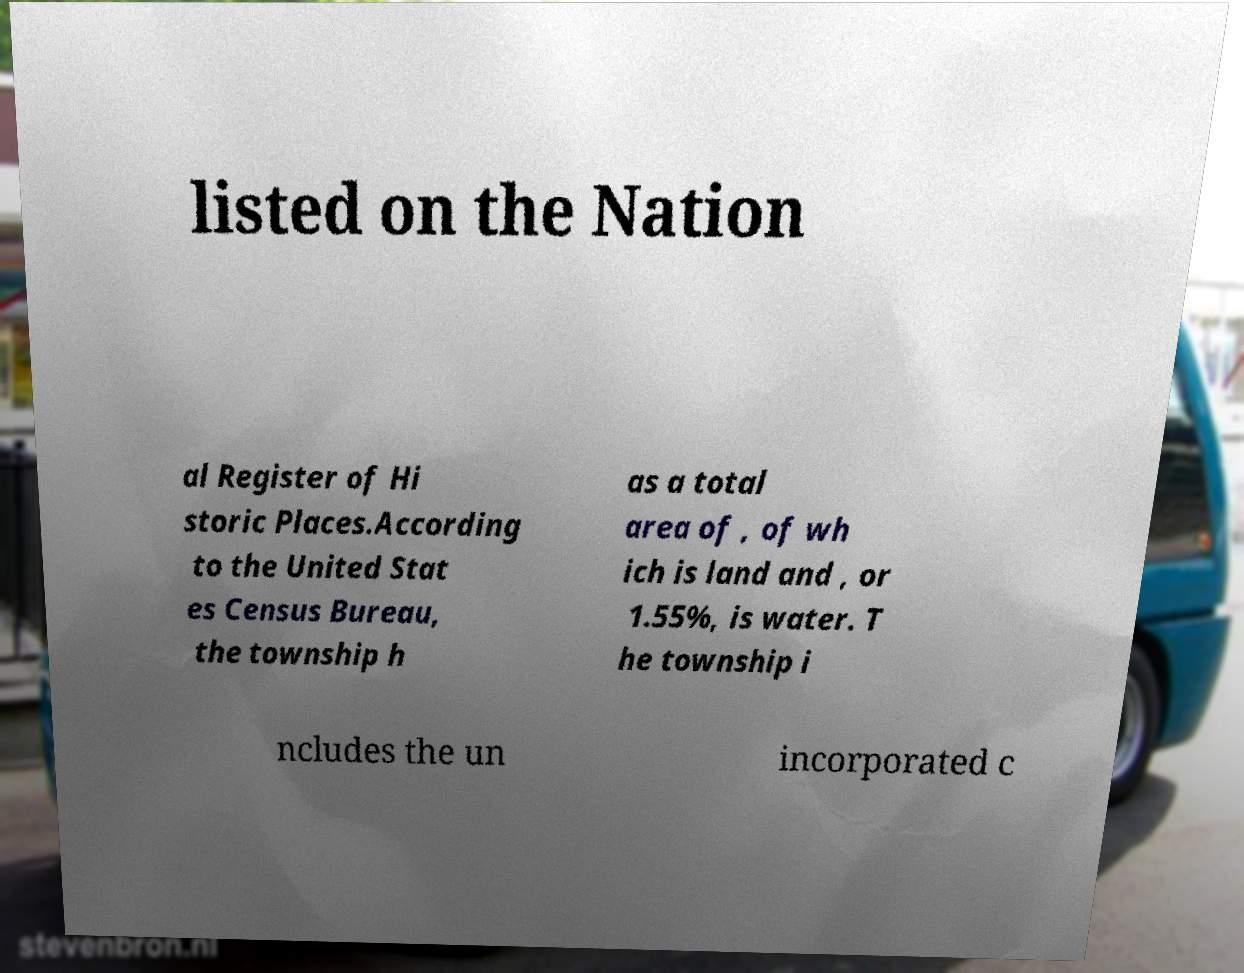Can you accurately transcribe the text from the provided image for me? listed on the Nation al Register of Hi storic Places.According to the United Stat es Census Bureau, the township h as a total area of , of wh ich is land and , or 1.55%, is water. T he township i ncludes the un incorporated c 